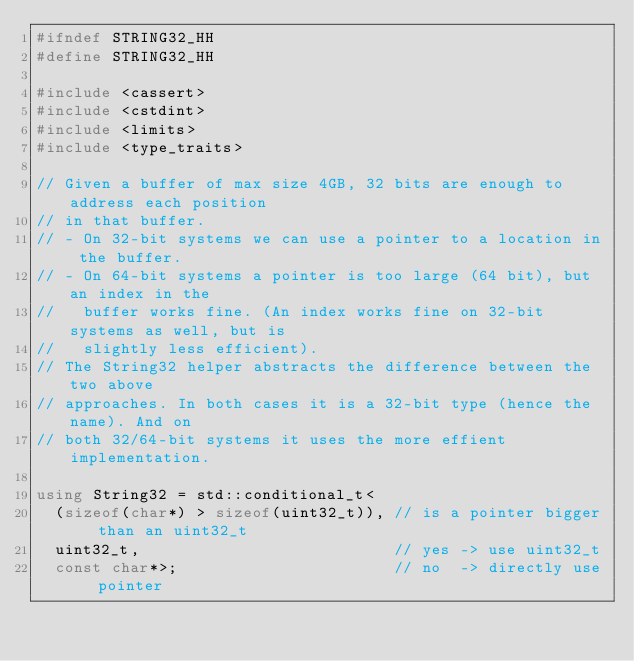<code> <loc_0><loc_0><loc_500><loc_500><_C++_>#ifndef STRING32_HH
#define STRING32_HH

#include <cassert>
#include <cstdint>
#include <limits>
#include <type_traits>

// Given a buffer of max size 4GB, 32 bits are enough to address each position
// in that buffer.
// - On 32-bit systems we can use a pointer to a location in the buffer.
// - On 64-bit systems a pointer is too large (64 bit), but an index in the
//   buffer works fine. (An index works fine on 32-bit systems as well, but is
//   slightly less efficient).
// The String32 helper abstracts the difference between the two above
// approaches. In both cases it is a 32-bit type (hence the name). And on
// both 32/64-bit systems it uses the more effient implementation.

using String32 = std::conditional_t<
	(sizeof(char*) > sizeof(uint32_t)), // is a pointer bigger than an uint32_t
	uint32_t,                           // yes -> use uint32_t
	const char*>;                       // no  -> directly use pointer
</code> 